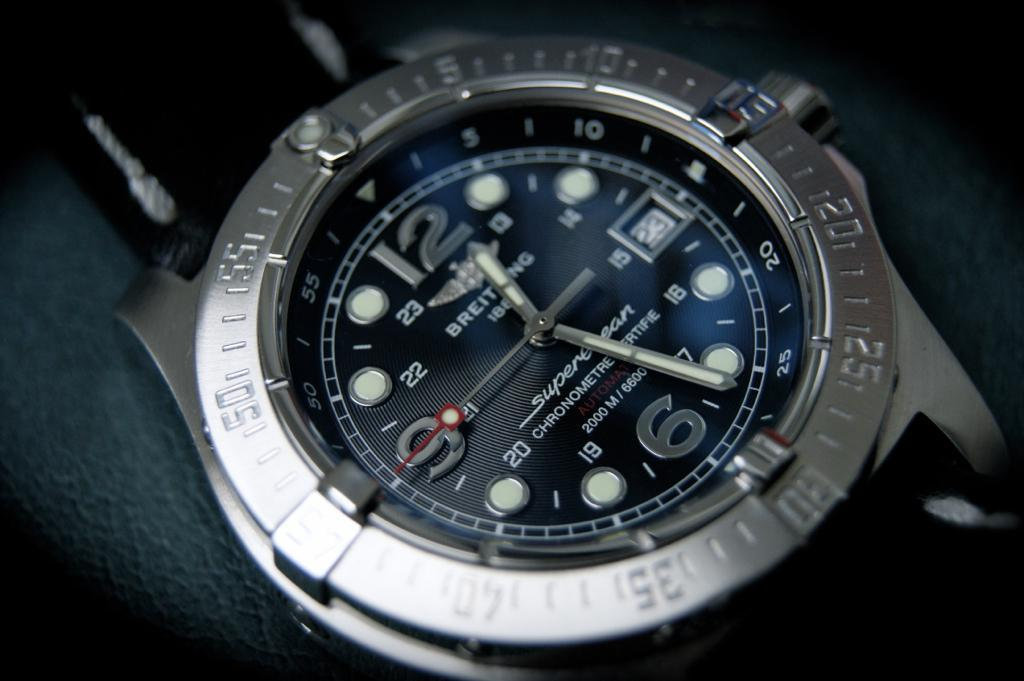<image>
Offer a succinct explanation of the picture presented. A men's watch says that today's date is the 23rd. 